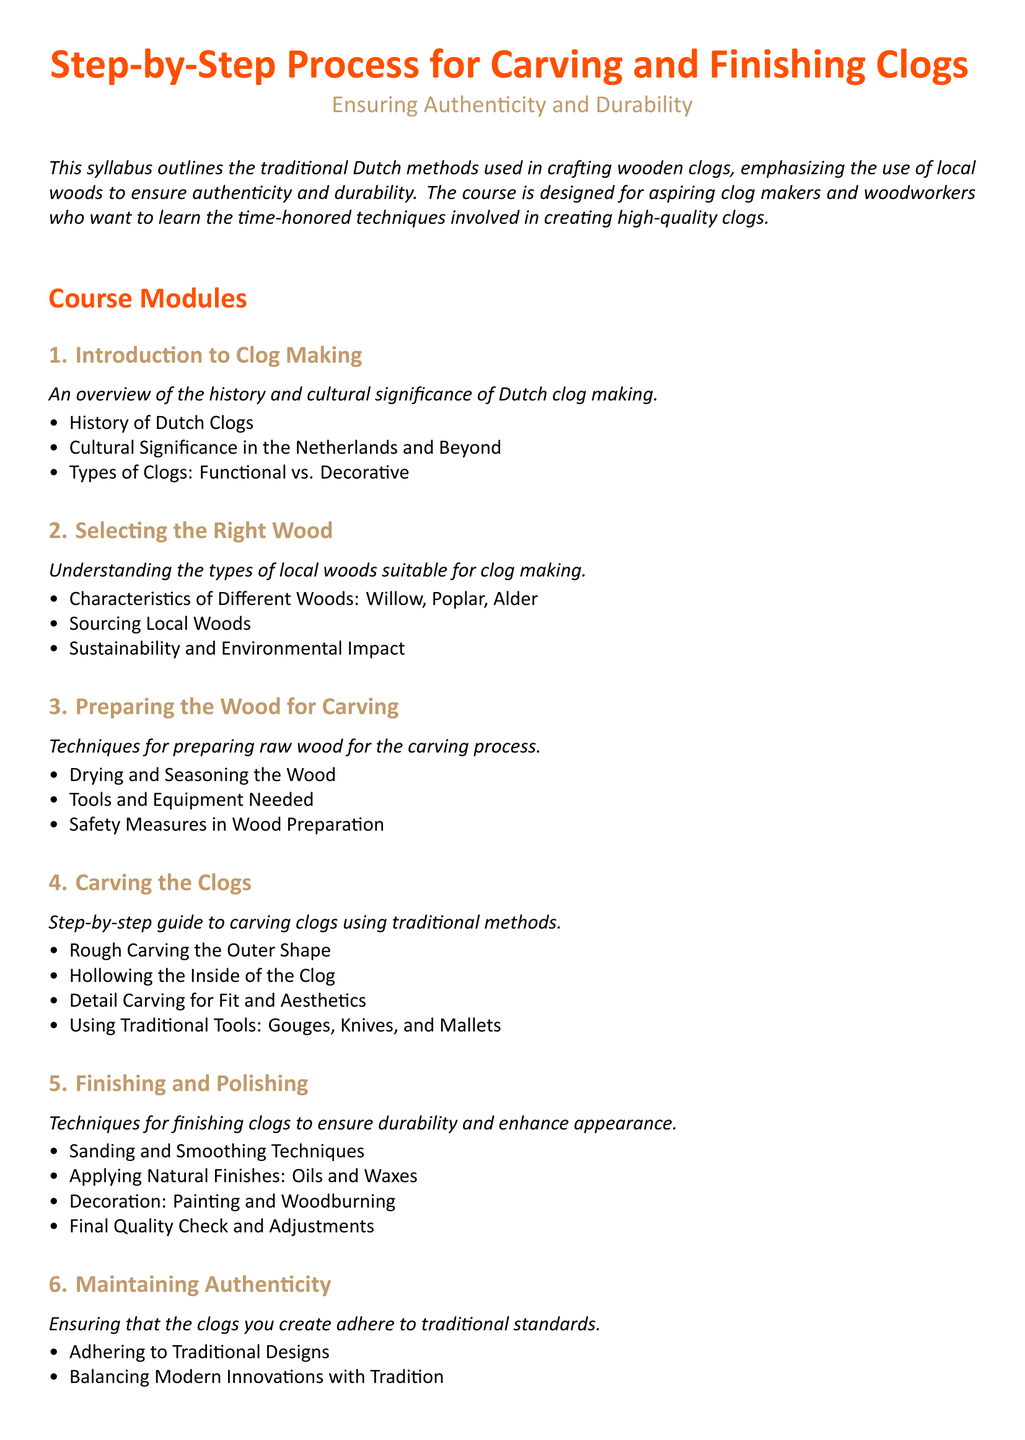What is the title of the syllabus? The title is prominently displayed at the top of the document, indicating the focus of the syllabus.
Answer: Step-by-Step Process for Carving and Finishing Clogs What wood types are mentioned for clog making? The syllabus specifies three types of local woods suitable for crafting clogs.
Answer: Willow, Poplar, Alder What is emphasized in the course? The document outlines a central theme regarding the methods and approaches to clog making.
Answer: Authenticity and Durability What is the second module about? This question refers to the organization of the syllabus, specifically the focus of the second module.
Answer: Selecting the Right Wood How many modules are there in total? The syllabus lists the different areas covered in clog making, which defines the number of modules.
Answer: Six What technique is used for applying finishes? The syllabus outlines the methods employed to enhance the durability and appearance of clogs in one of its modules.
Answer: Oils and Waxes What does the last module focus on? This question covers the thematic focus of the final module, which is important for maintaining standards.
Answer: Maintaining Authenticity Which traditional tools are used in the carving process? The syllabus provides specific examples of tools used, highlighting the traditional methods incorporated in the crafting process.
Answer: Gouges, Knives, and Mallets 